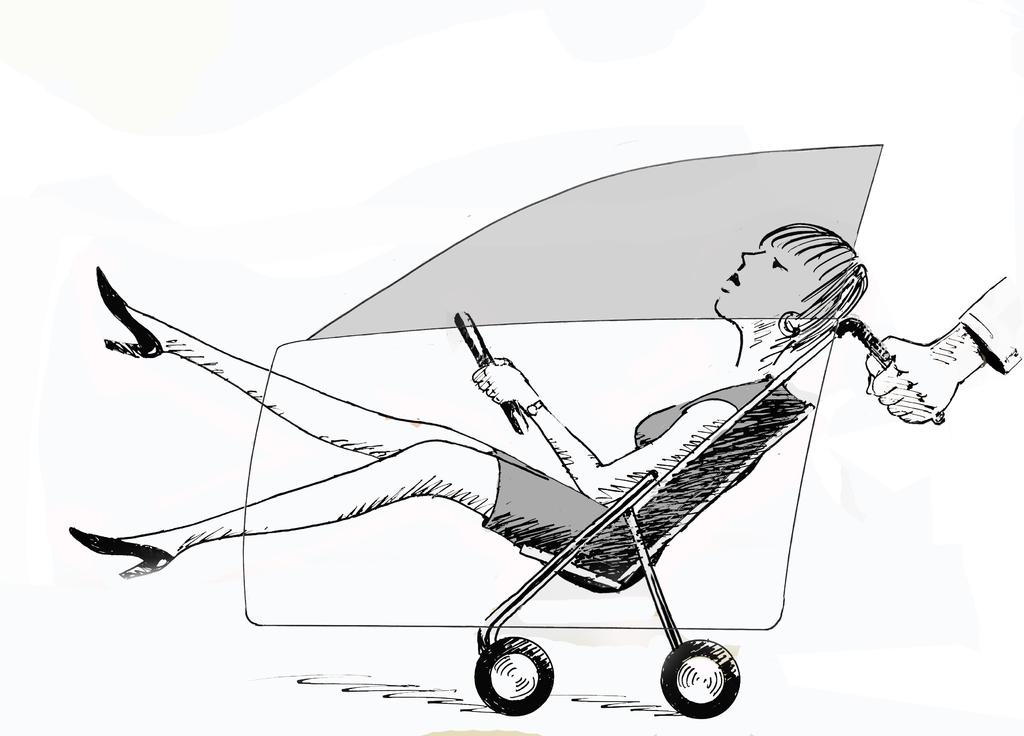What is depicted in the drawing in the image? There is a drawing of a person sitting on a wheelchair in the image. What can be seen on the right side of the image? There is another person's hand holding the wheelchair on the right side of the image. What color is the background of the image? The background of the image is in white color. How does the person sitting in the wheelchair take a bite of the snow in the image? There is no snow present in the image, and the person sitting in the wheelchair is not depicted as taking a bite of anything. 